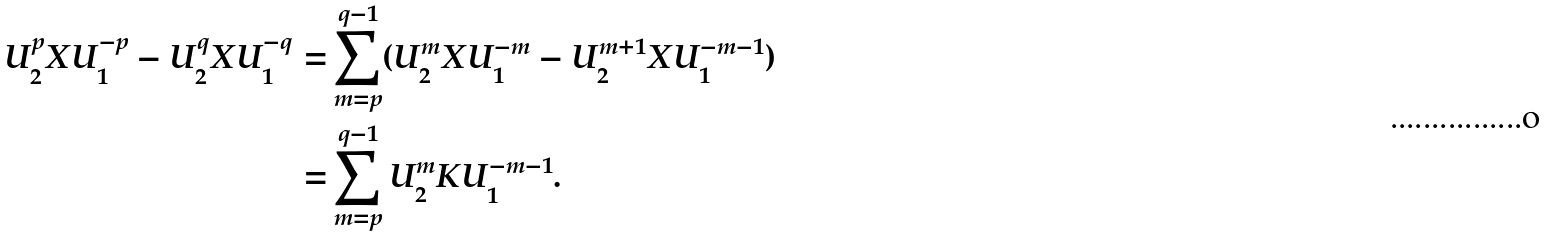Convert formula to latex. <formula><loc_0><loc_0><loc_500><loc_500>U _ { 2 } ^ { p } X U _ { 1 } ^ { - p } - U _ { 2 } ^ { q } X U _ { 1 } ^ { - q } = & \sum _ { m = p } ^ { q - 1 } ( U _ { 2 } ^ { m } X U _ { 1 } ^ { - m } - U _ { 2 } ^ { m + 1 } X U _ { 1 } ^ { - m - 1 } ) \\ = & \sum _ { m = p } ^ { q - 1 } U _ { 2 } ^ { m } K U _ { 1 } ^ { - m - 1 } .</formula> 